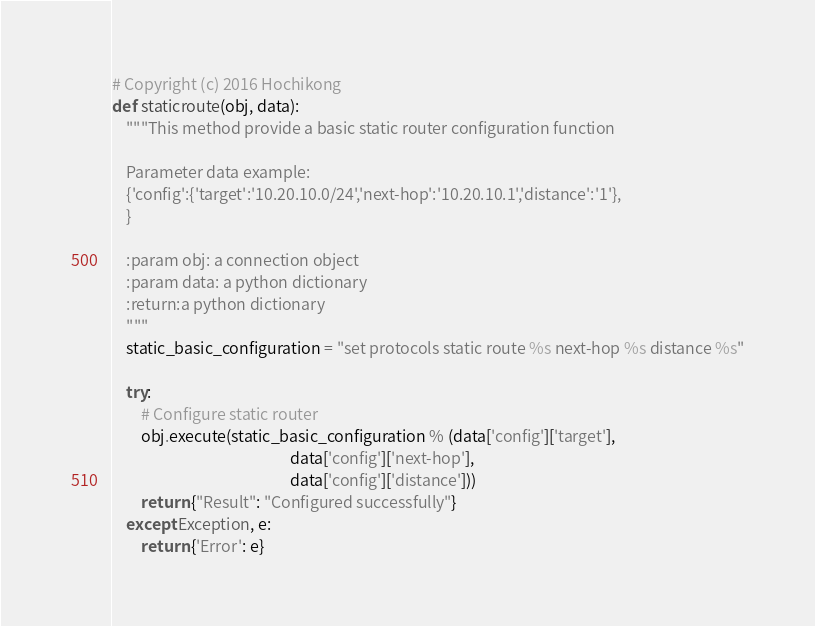<code> <loc_0><loc_0><loc_500><loc_500><_Python_># Copyright (c) 2016 Hochikong
def staticroute(obj, data):
    """This method provide a basic static router configuration function

    Parameter data example:
    {'config':{'target':'10.20.10.0/24','next-hop':'10.20.10.1','distance':'1'},
    }

    :param obj: a connection object
    :param data: a python dictionary
    :return:a python dictionary
    """
    static_basic_configuration = "set protocols static route %s next-hop %s distance %s"

    try:
        # Configure static router
        obj.execute(static_basic_configuration % (data['config']['target'],
                                                  data['config']['next-hop'],
                                                  data['config']['distance']))
        return {"Result": "Configured successfully"}
    except Exception, e:
        return {'Error': e}</code> 